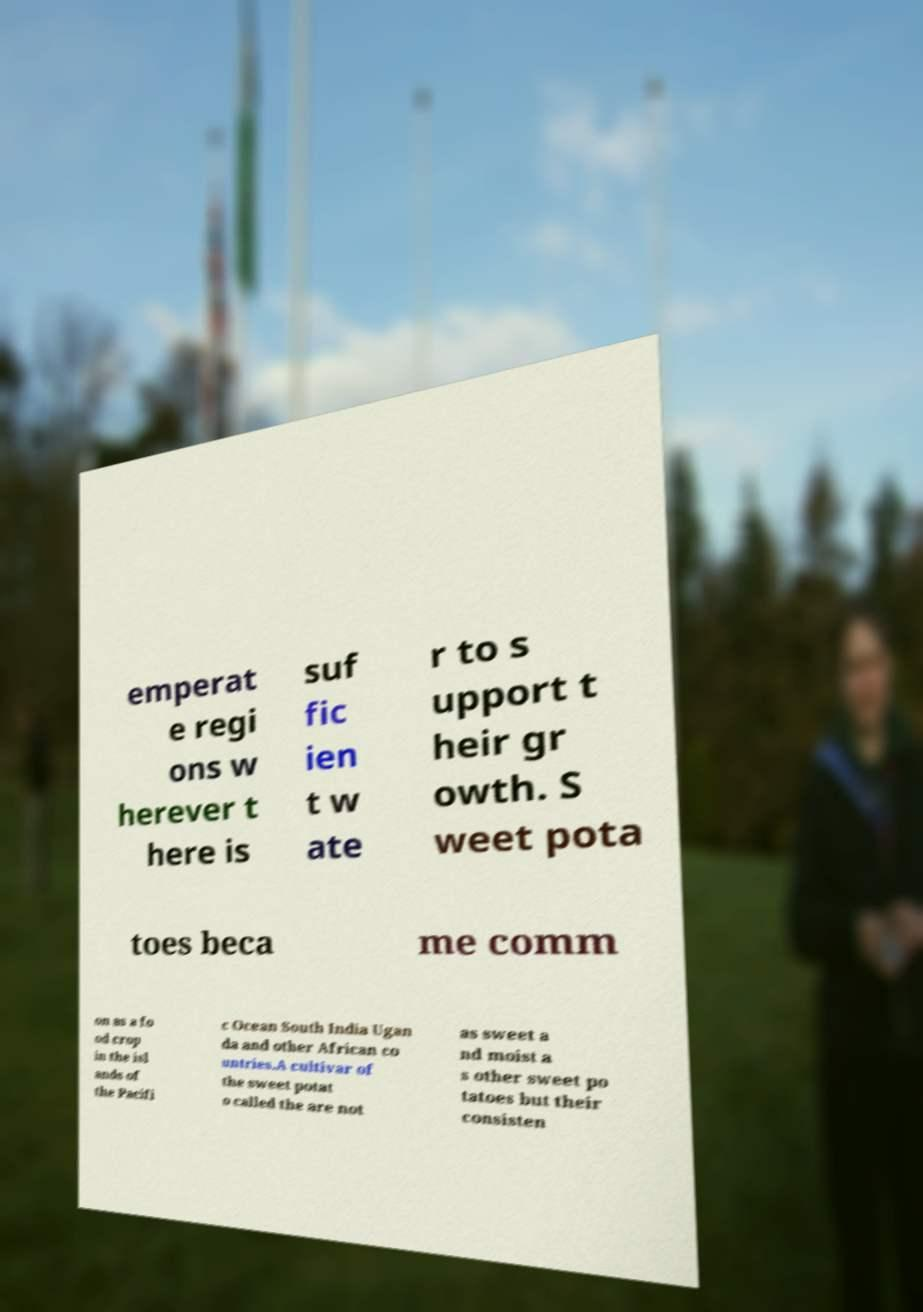Please read and relay the text visible in this image. What does it say? emperat e regi ons w herever t here is suf fic ien t w ate r to s upport t heir gr owth. S weet pota toes beca me comm on as a fo od crop in the isl ands of the Pacifi c Ocean South India Ugan da and other African co untries.A cultivar of the sweet potat o called the are not as sweet a nd moist a s other sweet po tatoes but their consisten 